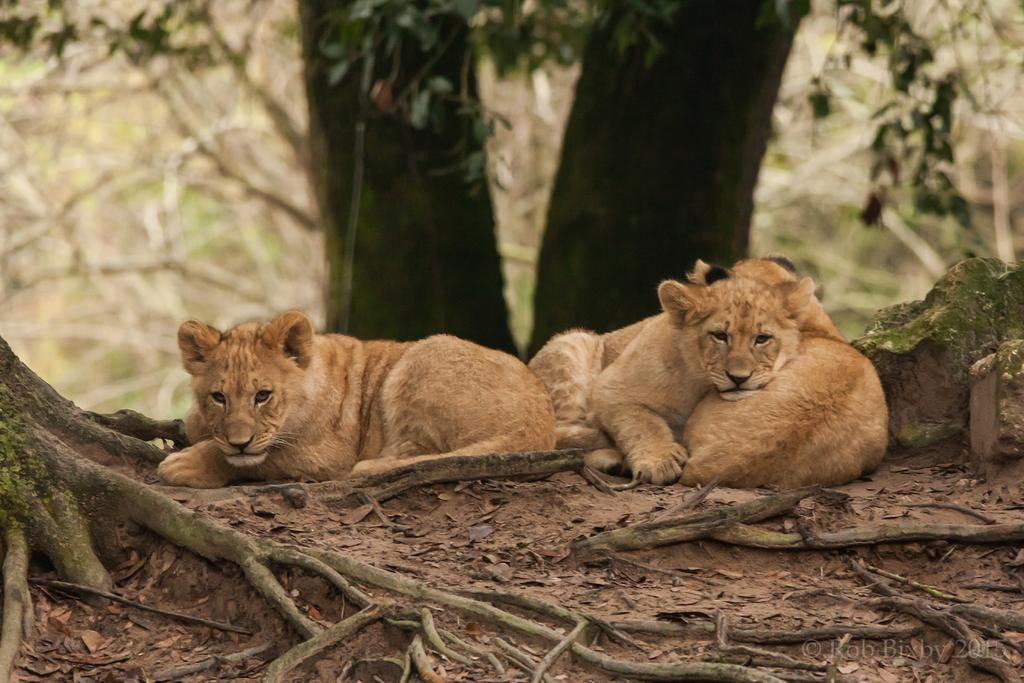What animals can be seen on the ground in the image? There are lion cubs on the ground in the image. What type of vegetation is present in the image? There are plants and trees in the image. What type of natural feature can be seen in the image? Rock stones are present in the image. What invention is being demonstrated by the lion cubs in the image? There is no invention being demonstrated by the lion cubs in the image; they are simply present on the ground. 